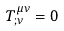Convert formula to latex. <formula><loc_0><loc_0><loc_500><loc_500>T ^ { \mu \nu } _ { ; \nu } = 0 \,</formula> 